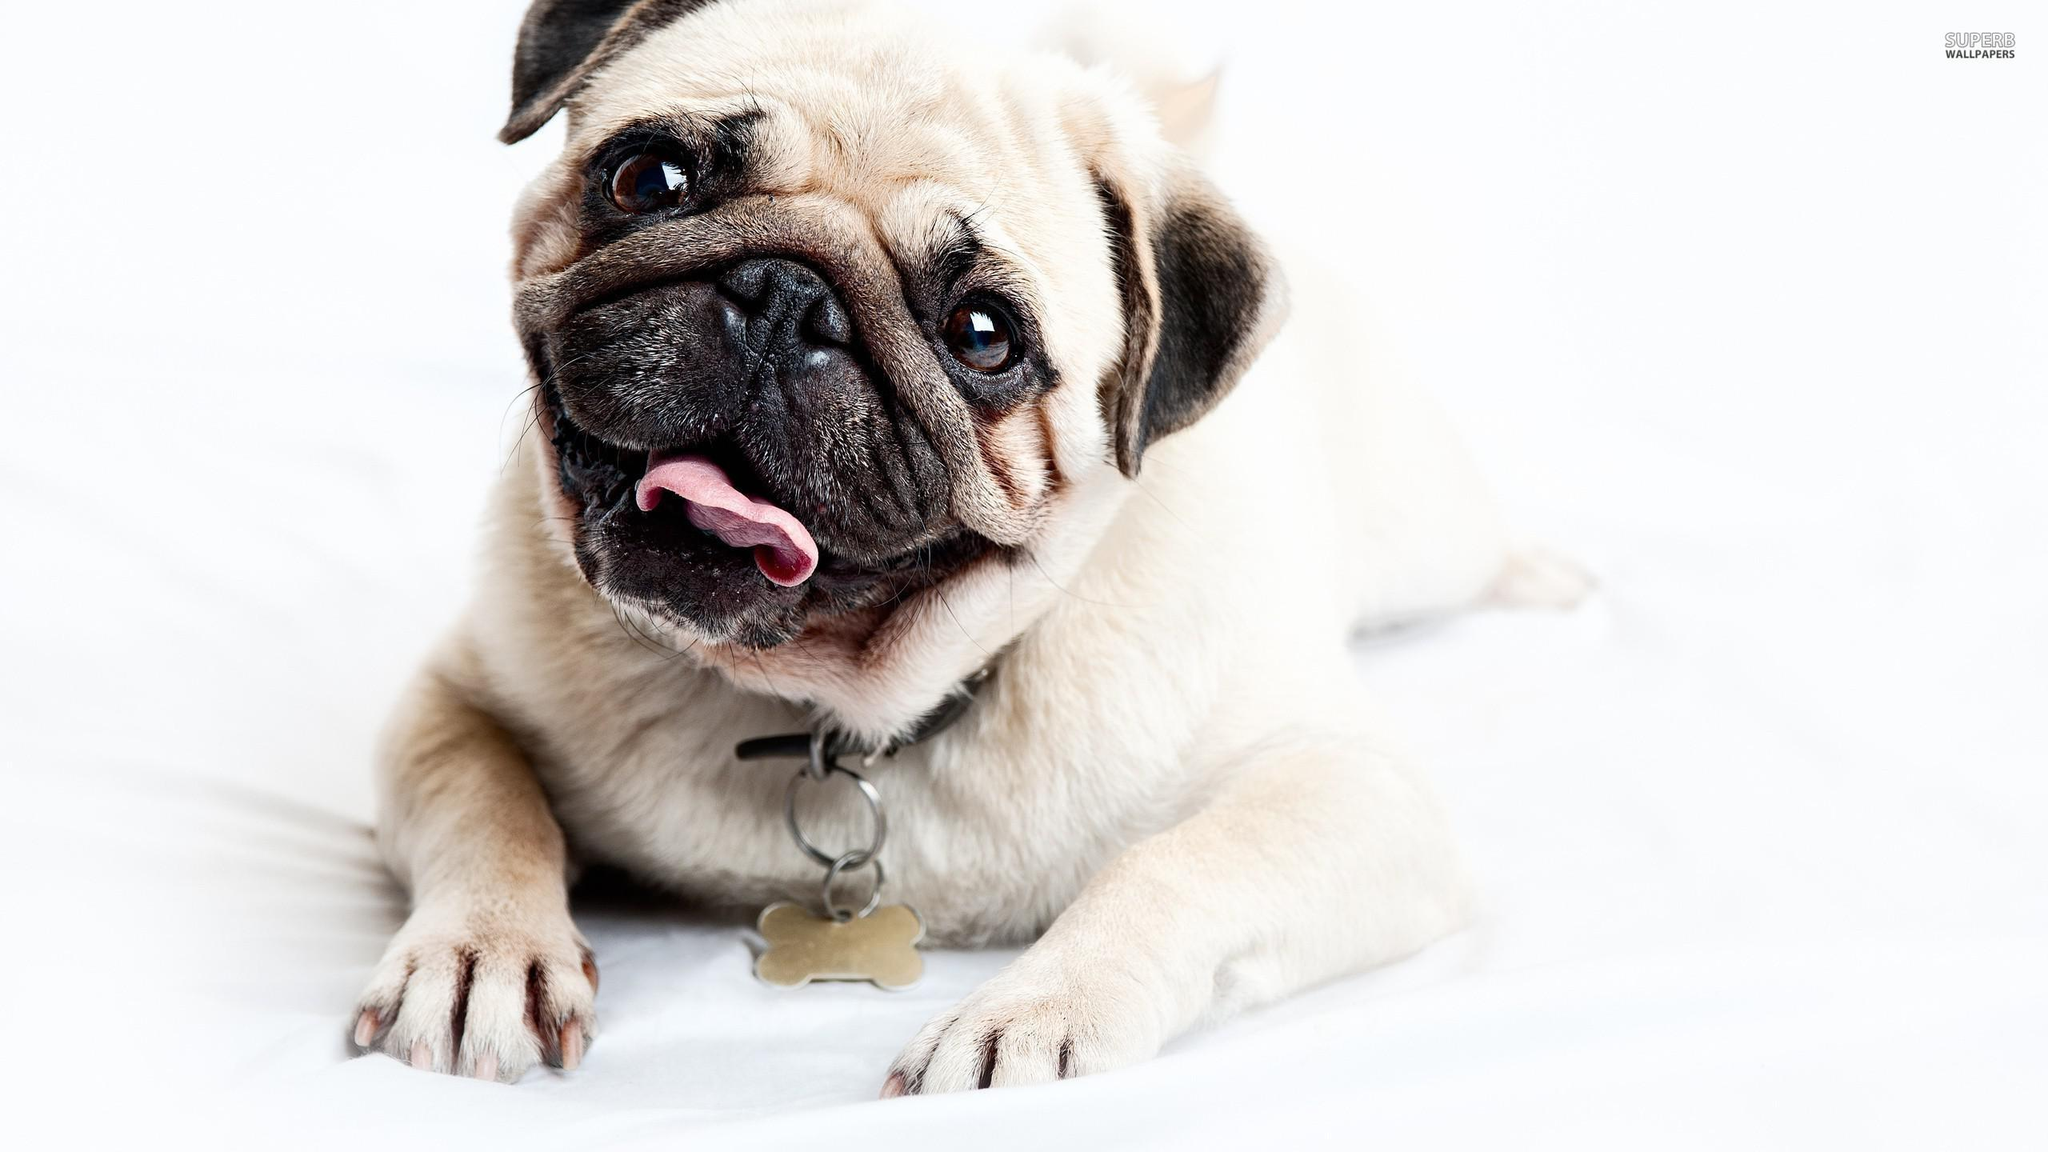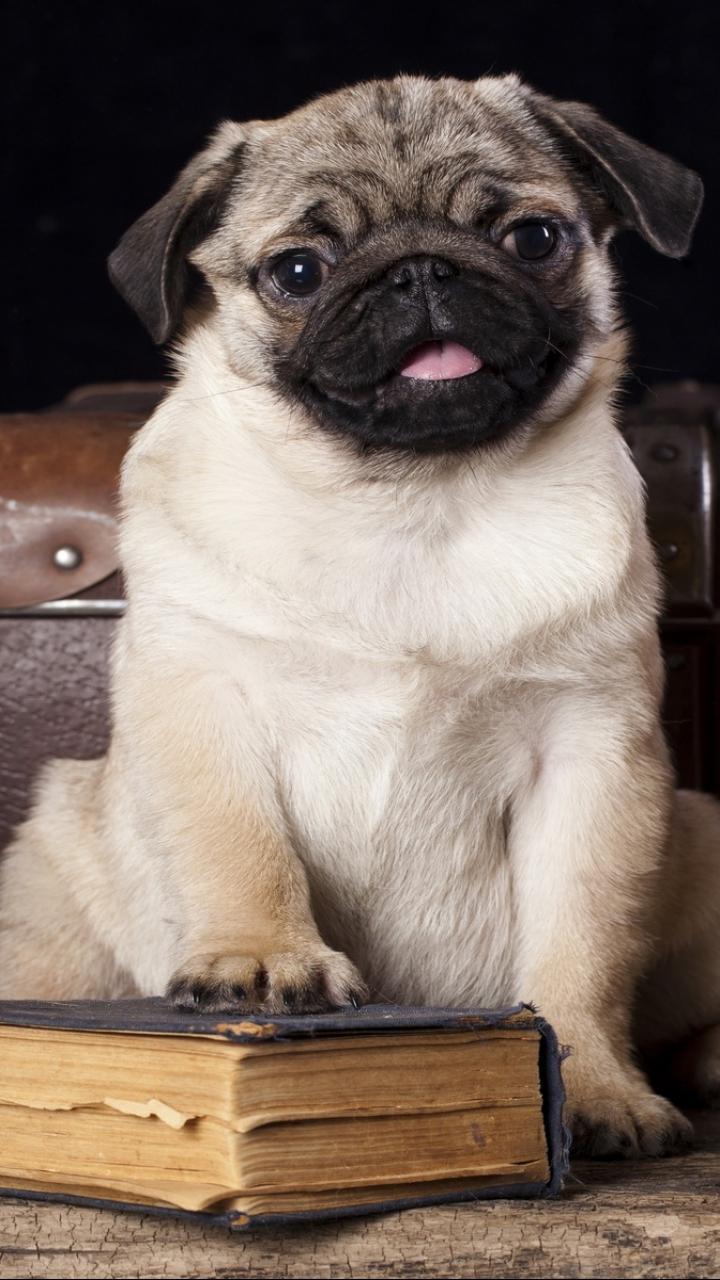The first image is the image on the left, the second image is the image on the right. Examine the images to the left and right. Is the description "The left image shows one pug reclining on its belly with its front paws forward and its head upright." accurate? Answer yes or no. Yes. The first image is the image on the left, the second image is the image on the right. Considering the images on both sides, is "At least one pug is wearing somehing on its neck." valid? Answer yes or no. Yes. 